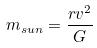Convert formula to latex. <formula><loc_0><loc_0><loc_500><loc_500>m _ { s u n } = \frac { r v ^ { 2 } } { G }</formula> 